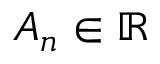<formula> <loc_0><loc_0><loc_500><loc_500>A _ { n } \in \mathbb { R }</formula> 